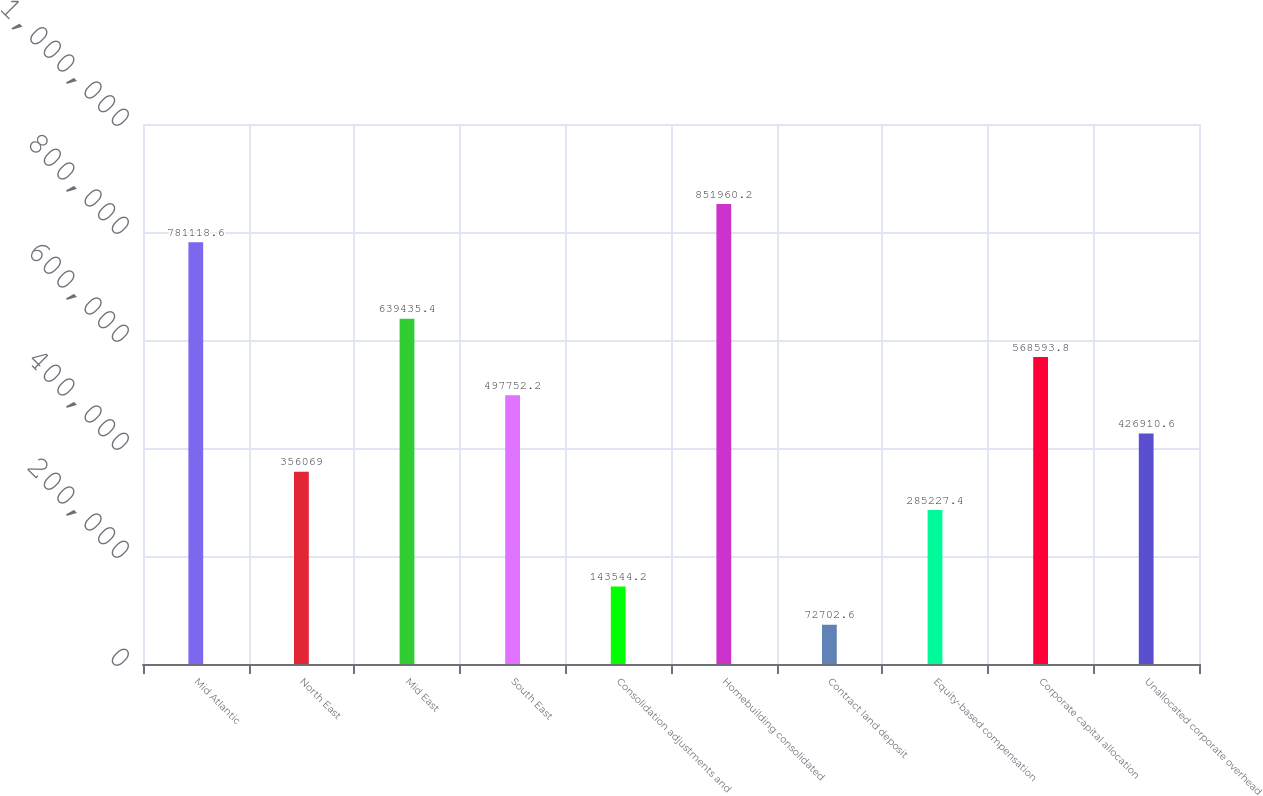<chart> <loc_0><loc_0><loc_500><loc_500><bar_chart><fcel>Mid Atlantic<fcel>North East<fcel>Mid East<fcel>South East<fcel>Consolidation adjustments and<fcel>Homebuilding consolidated<fcel>Contract land deposit<fcel>Equity-based compensation<fcel>Corporate capital allocation<fcel>Unallocated corporate overhead<nl><fcel>781119<fcel>356069<fcel>639435<fcel>497752<fcel>143544<fcel>851960<fcel>72702.6<fcel>285227<fcel>568594<fcel>426911<nl></chart> 